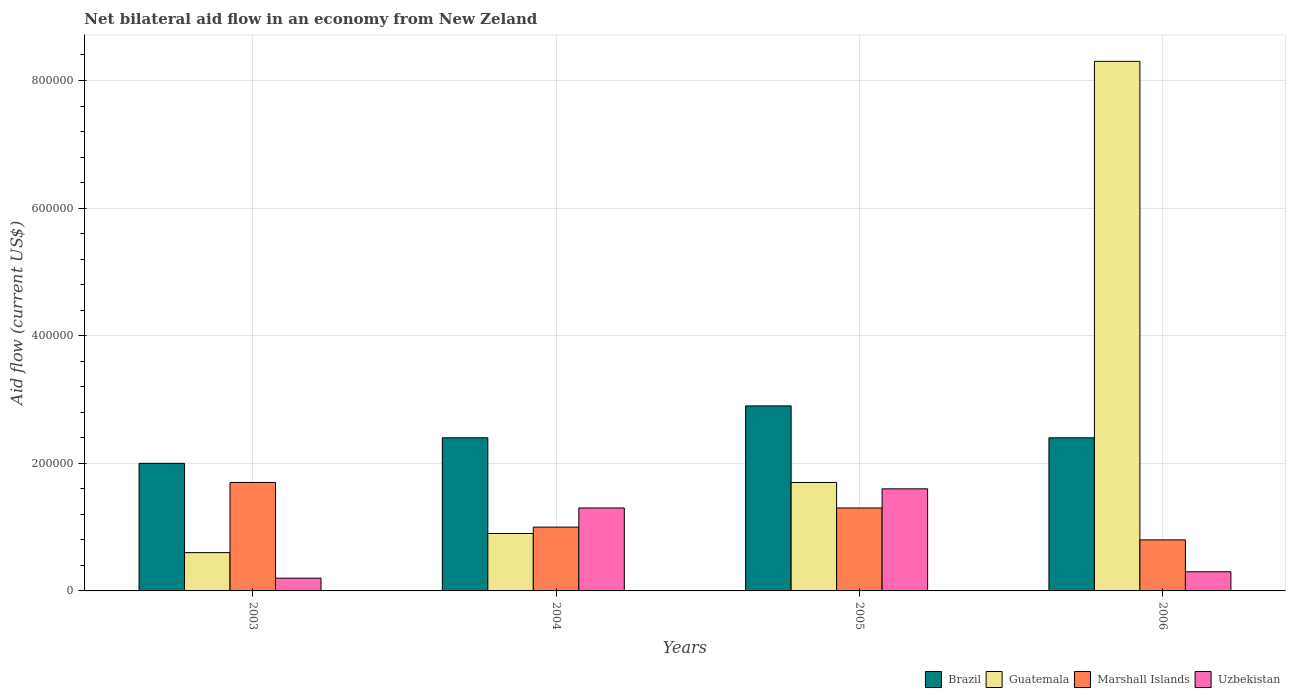How many different coloured bars are there?
Your answer should be compact. 4. Are the number of bars on each tick of the X-axis equal?
Provide a succinct answer. Yes. How many bars are there on the 4th tick from the left?
Offer a terse response. 4. How many bars are there on the 1st tick from the right?
Your answer should be compact. 4. What is the label of the 4th group of bars from the left?
Provide a succinct answer. 2006. What is the net bilateral aid flow in Guatemala in 2006?
Offer a very short reply. 8.30e+05. Across all years, what is the maximum net bilateral aid flow in Brazil?
Your answer should be very brief. 2.90e+05. Across all years, what is the minimum net bilateral aid flow in Guatemala?
Your answer should be very brief. 6.00e+04. What is the total net bilateral aid flow in Guatemala in the graph?
Provide a short and direct response. 1.15e+06. What is the difference between the net bilateral aid flow in Uzbekistan in 2003 and the net bilateral aid flow in Guatemala in 2006?
Provide a succinct answer. -8.10e+05. What is the average net bilateral aid flow in Guatemala per year?
Offer a very short reply. 2.88e+05. In how many years, is the net bilateral aid flow in Marshall Islands greater than 120000 US$?
Your answer should be compact. 2. What is the ratio of the net bilateral aid flow in Marshall Islands in 2003 to that in 2006?
Make the answer very short. 2.12. What is the difference between the highest and the second highest net bilateral aid flow in Brazil?
Make the answer very short. 5.00e+04. What is the difference between the highest and the lowest net bilateral aid flow in Marshall Islands?
Ensure brevity in your answer.  9.00e+04. What does the 3rd bar from the left in 2003 represents?
Provide a succinct answer. Marshall Islands. What does the 1st bar from the right in 2004 represents?
Your response must be concise. Uzbekistan. Is it the case that in every year, the sum of the net bilateral aid flow in Uzbekistan and net bilateral aid flow in Marshall Islands is greater than the net bilateral aid flow in Guatemala?
Make the answer very short. No. How many bars are there?
Offer a terse response. 16. Are all the bars in the graph horizontal?
Your response must be concise. No. What is the difference between two consecutive major ticks on the Y-axis?
Your answer should be compact. 2.00e+05. How many legend labels are there?
Offer a very short reply. 4. How are the legend labels stacked?
Your answer should be very brief. Horizontal. What is the title of the graph?
Keep it short and to the point. Net bilateral aid flow in an economy from New Zeland. Does "Heavily indebted poor countries" appear as one of the legend labels in the graph?
Ensure brevity in your answer.  No. What is the Aid flow (current US$) of Brazil in 2003?
Your response must be concise. 2.00e+05. What is the Aid flow (current US$) in Marshall Islands in 2003?
Give a very brief answer. 1.70e+05. What is the Aid flow (current US$) in Brazil in 2004?
Provide a short and direct response. 2.40e+05. What is the Aid flow (current US$) of Guatemala in 2004?
Provide a short and direct response. 9.00e+04. What is the Aid flow (current US$) in Marshall Islands in 2004?
Give a very brief answer. 1.00e+05. What is the Aid flow (current US$) in Brazil in 2006?
Offer a very short reply. 2.40e+05. What is the Aid flow (current US$) of Guatemala in 2006?
Keep it short and to the point. 8.30e+05. What is the Aid flow (current US$) in Marshall Islands in 2006?
Ensure brevity in your answer.  8.00e+04. What is the Aid flow (current US$) in Uzbekistan in 2006?
Offer a very short reply. 3.00e+04. Across all years, what is the maximum Aid flow (current US$) of Guatemala?
Ensure brevity in your answer.  8.30e+05. Across all years, what is the maximum Aid flow (current US$) in Marshall Islands?
Give a very brief answer. 1.70e+05. Across all years, what is the minimum Aid flow (current US$) in Brazil?
Offer a terse response. 2.00e+05. Across all years, what is the minimum Aid flow (current US$) in Guatemala?
Keep it short and to the point. 6.00e+04. What is the total Aid flow (current US$) of Brazil in the graph?
Offer a terse response. 9.70e+05. What is the total Aid flow (current US$) of Guatemala in the graph?
Offer a terse response. 1.15e+06. What is the total Aid flow (current US$) of Marshall Islands in the graph?
Ensure brevity in your answer.  4.80e+05. What is the total Aid flow (current US$) in Uzbekistan in the graph?
Your response must be concise. 3.40e+05. What is the difference between the Aid flow (current US$) of Brazil in 2003 and that in 2004?
Offer a terse response. -4.00e+04. What is the difference between the Aid flow (current US$) in Uzbekistan in 2003 and that in 2004?
Your answer should be compact. -1.10e+05. What is the difference between the Aid flow (current US$) in Brazil in 2003 and that in 2005?
Provide a short and direct response. -9.00e+04. What is the difference between the Aid flow (current US$) in Marshall Islands in 2003 and that in 2005?
Ensure brevity in your answer.  4.00e+04. What is the difference between the Aid flow (current US$) in Brazil in 2003 and that in 2006?
Your response must be concise. -4.00e+04. What is the difference between the Aid flow (current US$) in Guatemala in 2003 and that in 2006?
Keep it short and to the point. -7.70e+05. What is the difference between the Aid flow (current US$) of Brazil in 2004 and that in 2005?
Ensure brevity in your answer.  -5.00e+04. What is the difference between the Aid flow (current US$) of Guatemala in 2004 and that in 2005?
Your response must be concise. -8.00e+04. What is the difference between the Aid flow (current US$) in Marshall Islands in 2004 and that in 2005?
Provide a short and direct response. -3.00e+04. What is the difference between the Aid flow (current US$) in Brazil in 2004 and that in 2006?
Offer a very short reply. 0. What is the difference between the Aid flow (current US$) of Guatemala in 2004 and that in 2006?
Make the answer very short. -7.40e+05. What is the difference between the Aid flow (current US$) of Marshall Islands in 2004 and that in 2006?
Keep it short and to the point. 2.00e+04. What is the difference between the Aid flow (current US$) in Guatemala in 2005 and that in 2006?
Your answer should be compact. -6.60e+05. What is the difference between the Aid flow (current US$) in Brazil in 2003 and the Aid flow (current US$) in Marshall Islands in 2004?
Make the answer very short. 1.00e+05. What is the difference between the Aid flow (current US$) in Brazil in 2003 and the Aid flow (current US$) in Uzbekistan in 2004?
Your response must be concise. 7.00e+04. What is the difference between the Aid flow (current US$) in Brazil in 2003 and the Aid flow (current US$) in Marshall Islands in 2005?
Your response must be concise. 7.00e+04. What is the difference between the Aid flow (current US$) in Guatemala in 2003 and the Aid flow (current US$) in Marshall Islands in 2005?
Provide a succinct answer. -7.00e+04. What is the difference between the Aid flow (current US$) of Marshall Islands in 2003 and the Aid flow (current US$) of Uzbekistan in 2005?
Your response must be concise. 10000. What is the difference between the Aid flow (current US$) of Brazil in 2003 and the Aid flow (current US$) of Guatemala in 2006?
Offer a very short reply. -6.30e+05. What is the difference between the Aid flow (current US$) of Brazil in 2003 and the Aid flow (current US$) of Uzbekistan in 2006?
Your answer should be very brief. 1.70e+05. What is the difference between the Aid flow (current US$) of Guatemala in 2003 and the Aid flow (current US$) of Marshall Islands in 2006?
Give a very brief answer. -2.00e+04. What is the difference between the Aid flow (current US$) of Guatemala in 2003 and the Aid flow (current US$) of Uzbekistan in 2006?
Offer a terse response. 3.00e+04. What is the difference between the Aid flow (current US$) in Brazil in 2004 and the Aid flow (current US$) in Guatemala in 2005?
Make the answer very short. 7.00e+04. What is the difference between the Aid flow (current US$) of Brazil in 2004 and the Aid flow (current US$) of Marshall Islands in 2005?
Your response must be concise. 1.10e+05. What is the difference between the Aid flow (current US$) of Brazil in 2004 and the Aid flow (current US$) of Guatemala in 2006?
Give a very brief answer. -5.90e+05. What is the difference between the Aid flow (current US$) in Brazil in 2004 and the Aid flow (current US$) in Uzbekistan in 2006?
Offer a terse response. 2.10e+05. What is the difference between the Aid flow (current US$) in Marshall Islands in 2004 and the Aid flow (current US$) in Uzbekistan in 2006?
Your answer should be compact. 7.00e+04. What is the difference between the Aid flow (current US$) in Brazil in 2005 and the Aid flow (current US$) in Guatemala in 2006?
Make the answer very short. -5.40e+05. What is the difference between the Aid flow (current US$) of Marshall Islands in 2005 and the Aid flow (current US$) of Uzbekistan in 2006?
Keep it short and to the point. 1.00e+05. What is the average Aid flow (current US$) of Brazil per year?
Provide a short and direct response. 2.42e+05. What is the average Aid flow (current US$) in Guatemala per year?
Offer a very short reply. 2.88e+05. What is the average Aid flow (current US$) of Marshall Islands per year?
Make the answer very short. 1.20e+05. What is the average Aid flow (current US$) of Uzbekistan per year?
Offer a very short reply. 8.50e+04. In the year 2003, what is the difference between the Aid flow (current US$) in Brazil and Aid flow (current US$) in Guatemala?
Offer a very short reply. 1.40e+05. In the year 2003, what is the difference between the Aid flow (current US$) in Brazil and Aid flow (current US$) in Uzbekistan?
Ensure brevity in your answer.  1.80e+05. In the year 2003, what is the difference between the Aid flow (current US$) in Guatemala and Aid flow (current US$) in Marshall Islands?
Your answer should be very brief. -1.10e+05. In the year 2003, what is the difference between the Aid flow (current US$) of Marshall Islands and Aid flow (current US$) of Uzbekistan?
Your answer should be compact. 1.50e+05. In the year 2004, what is the difference between the Aid flow (current US$) in Brazil and Aid flow (current US$) in Guatemala?
Offer a terse response. 1.50e+05. In the year 2004, what is the difference between the Aid flow (current US$) in Guatemala and Aid flow (current US$) in Uzbekistan?
Your answer should be very brief. -4.00e+04. In the year 2004, what is the difference between the Aid flow (current US$) in Marshall Islands and Aid flow (current US$) in Uzbekistan?
Make the answer very short. -3.00e+04. In the year 2005, what is the difference between the Aid flow (current US$) of Marshall Islands and Aid flow (current US$) of Uzbekistan?
Provide a succinct answer. -3.00e+04. In the year 2006, what is the difference between the Aid flow (current US$) in Brazil and Aid flow (current US$) in Guatemala?
Offer a terse response. -5.90e+05. In the year 2006, what is the difference between the Aid flow (current US$) in Guatemala and Aid flow (current US$) in Marshall Islands?
Your answer should be very brief. 7.50e+05. In the year 2006, what is the difference between the Aid flow (current US$) of Guatemala and Aid flow (current US$) of Uzbekistan?
Offer a very short reply. 8.00e+05. In the year 2006, what is the difference between the Aid flow (current US$) of Marshall Islands and Aid flow (current US$) of Uzbekistan?
Offer a terse response. 5.00e+04. What is the ratio of the Aid flow (current US$) in Guatemala in 2003 to that in 2004?
Your answer should be very brief. 0.67. What is the ratio of the Aid flow (current US$) of Marshall Islands in 2003 to that in 2004?
Provide a short and direct response. 1.7. What is the ratio of the Aid flow (current US$) in Uzbekistan in 2003 to that in 2004?
Your answer should be compact. 0.15. What is the ratio of the Aid flow (current US$) in Brazil in 2003 to that in 2005?
Make the answer very short. 0.69. What is the ratio of the Aid flow (current US$) of Guatemala in 2003 to that in 2005?
Provide a short and direct response. 0.35. What is the ratio of the Aid flow (current US$) of Marshall Islands in 2003 to that in 2005?
Offer a very short reply. 1.31. What is the ratio of the Aid flow (current US$) of Guatemala in 2003 to that in 2006?
Your answer should be compact. 0.07. What is the ratio of the Aid flow (current US$) of Marshall Islands in 2003 to that in 2006?
Make the answer very short. 2.12. What is the ratio of the Aid flow (current US$) in Brazil in 2004 to that in 2005?
Provide a succinct answer. 0.83. What is the ratio of the Aid flow (current US$) in Guatemala in 2004 to that in 2005?
Offer a terse response. 0.53. What is the ratio of the Aid flow (current US$) of Marshall Islands in 2004 to that in 2005?
Your response must be concise. 0.77. What is the ratio of the Aid flow (current US$) in Uzbekistan in 2004 to that in 2005?
Ensure brevity in your answer.  0.81. What is the ratio of the Aid flow (current US$) in Brazil in 2004 to that in 2006?
Provide a short and direct response. 1. What is the ratio of the Aid flow (current US$) of Guatemala in 2004 to that in 2006?
Your answer should be very brief. 0.11. What is the ratio of the Aid flow (current US$) of Uzbekistan in 2004 to that in 2006?
Give a very brief answer. 4.33. What is the ratio of the Aid flow (current US$) in Brazil in 2005 to that in 2006?
Offer a terse response. 1.21. What is the ratio of the Aid flow (current US$) in Guatemala in 2005 to that in 2006?
Keep it short and to the point. 0.2. What is the ratio of the Aid flow (current US$) of Marshall Islands in 2005 to that in 2006?
Provide a short and direct response. 1.62. What is the ratio of the Aid flow (current US$) of Uzbekistan in 2005 to that in 2006?
Keep it short and to the point. 5.33. What is the difference between the highest and the second highest Aid flow (current US$) in Brazil?
Your response must be concise. 5.00e+04. What is the difference between the highest and the second highest Aid flow (current US$) in Marshall Islands?
Provide a succinct answer. 4.00e+04. What is the difference between the highest and the lowest Aid flow (current US$) in Guatemala?
Provide a short and direct response. 7.70e+05. What is the difference between the highest and the lowest Aid flow (current US$) in Marshall Islands?
Your answer should be compact. 9.00e+04. 